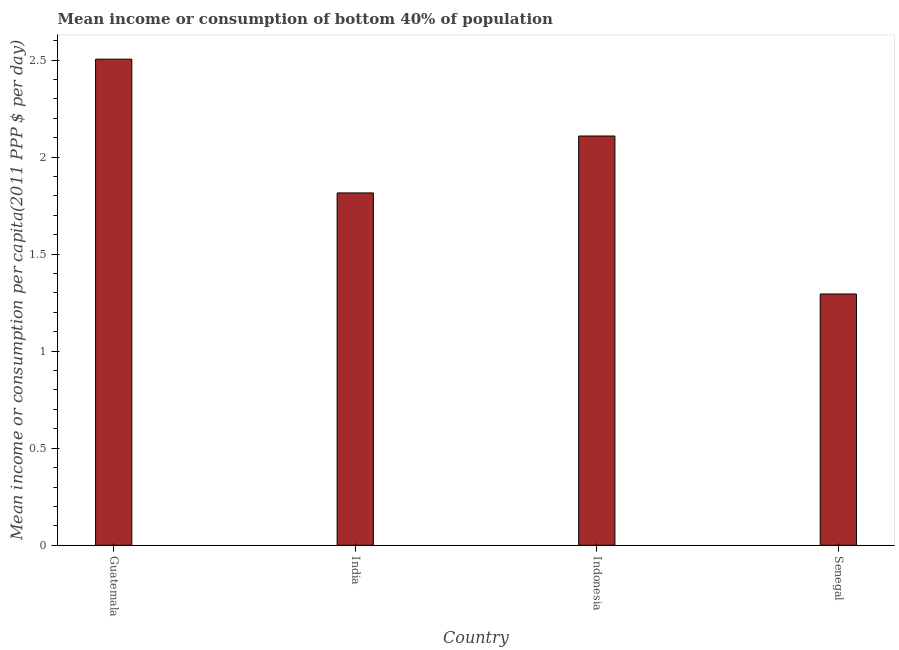What is the title of the graph?
Ensure brevity in your answer.  Mean income or consumption of bottom 40% of population. What is the label or title of the Y-axis?
Keep it short and to the point. Mean income or consumption per capita(2011 PPP $ per day). What is the mean income or consumption in Indonesia?
Your response must be concise. 2.11. Across all countries, what is the maximum mean income or consumption?
Your answer should be compact. 2.5. Across all countries, what is the minimum mean income or consumption?
Give a very brief answer. 1.29. In which country was the mean income or consumption maximum?
Provide a short and direct response. Guatemala. In which country was the mean income or consumption minimum?
Offer a terse response. Senegal. What is the sum of the mean income or consumption?
Your answer should be compact. 7.72. What is the difference between the mean income or consumption in India and Indonesia?
Offer a very short reply. -0.29. What is the average mean income or consumption per country?
Your response must be concise. 1.93. What is the median mean income or consumption?
Offer a very short reply. 1.96. What is the ratio of the mean income or consumption in Guatemala to that in Senegal?
Keep it short and to the point. 1.94. Is the difference between the mean income or consumption in Guatemala and India greater than the difference between any two countries?
Your answer should be compact. No. What is the difference between the highest and the second highest mean income or consumption?
Make the answer very short. 0.4. Is the sum of the mean income or consumption in India and Senegal greater than the maximum mean income or consumption across all countries?
Offer a terse response. Yes. What is the difference between the highest and the lowest mean income or consumption?
Offer a very short reply. 1.21. How many bars are there?
Offer a terse response. 4. Are all the bars in the graph horizontal?
Offer a very short reply. No. How many countries are there in the graph?
Make the answer very short. 4. What is the Mean income or consumption per capita(2011 PPP $ per day) in Guatemala?
Your answer should be compact. 2.5. What is the Mean income or consumption per capita(2011 PPP $ per day) in India?
Provide a succinct answer. 1.82. What is the Mean income or consumption per capita(2011 PPP $ per day) of Indonesia?
Make the answer very short. 2.11. What is the Mean income or consumption per capita(2011 PPP $ per day) of Senegal?
Keep it short and to the point. 1.29. What is the difference between the Mean income or consumption per capita(2011 PPP $ per day) in Guatemala and India?
Your answer should be compact. 0.69. What is the difference between the Mean income or consumption per capita(2011 PPP $ per day) in Guatemala and Indonesia?
Make the answer very short. 0.4. What is the difference between the Mean income or consumption per capita(2011 PPP $ per day) in Guatemala and Senegal?
Make the answer very short. 1.21. What is the difference between the Mean income or consumption per capita(2011 PPP $ per day) in India and Indonesia?
Ensure brevity in your answer.  -0.29. What is the difference between the Mean income or consumption per capita(2011 PPP $ per day) in India and Senegal?
Your answer should be very brief. 0.52. What is the difference between the Mean income or consumption per capita(2011 PPP $ per day) in Indonesia and Senegal?
Provide a succinct answer. 0.81. What is the ratio of the Mean income or consumption per capita(2011 PPP $ per day) in Guatemala to that in India?
Your response must be concise. 1.38. What is the ratio of the Mean income or consumption per capita(2011 PPP $ per day) in Guatemala to that in Indonesia?
Ensure brevity in your answer.  1.19. What is the ratio of the Mean income or consumption per capita(2011 PPP $ per day) in Guatemala to that in Senegal?
Your answer should be very brief. 1.94. What is the ratio of the Mean income or consumption per capita(2011 PPP $ per day) in India to that in Indonesia?
Your answer should be compact. 0.86. What is the ratio of the Mean income or consumption per capita(2011 PPP $ per day) in India to that in Senegal?
Keep it short and to the point. 1.4. What is the ratio of the Mean income or consumption per capita(2011 PPP $ per day) in Indonesia to that in Senegal?
Offer a terse response. 1.63. 